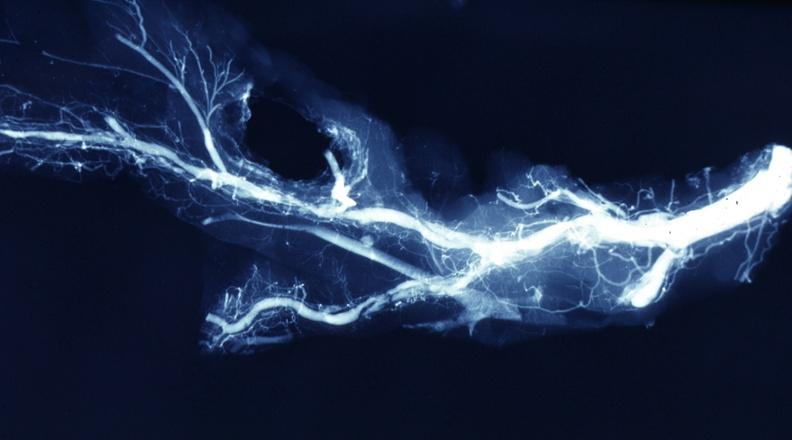s liver present?
Answer the question using a single word or phrase. No 